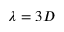<formula> <loc_0><loc_0><loc_500><loc_500>\lambda = 3 D</formula> 